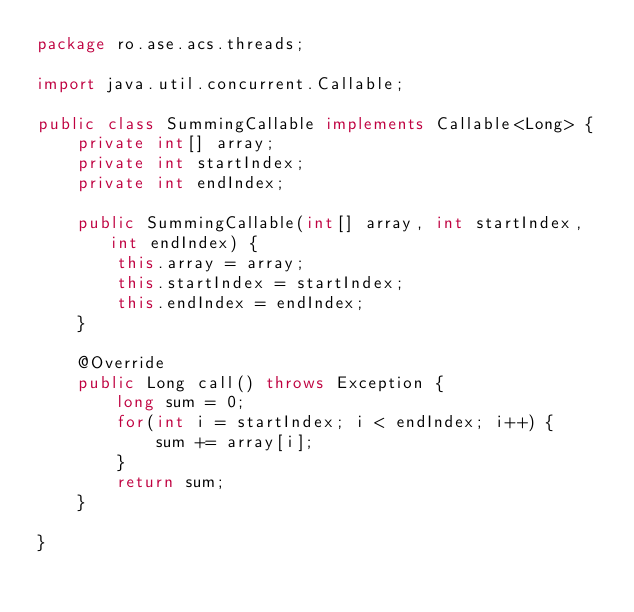<code> <loc_0><loc_0><loc_500><loc_500><_Java_>package ro.ase.acs.threads;

import java.util.concurrent.Callable;

public class SummingCallable implements Callable<Long> {
	private int[] array;
	private int startIndex;
	private int endIndex;
	
	public SummingCallable(int[] array, int startIndex, int endIndex) {
		this.array = array;
		this.startIndex = startIndex;
		this.endIndex = endIndex;
	}
	
	@Override
	public Long call() throws Exception {
		long sum = 0;
		for(int i = startIndex; i < endIndex; i++) {
			sum += array[i];
		}
		return sum;
	}

}
</code> 